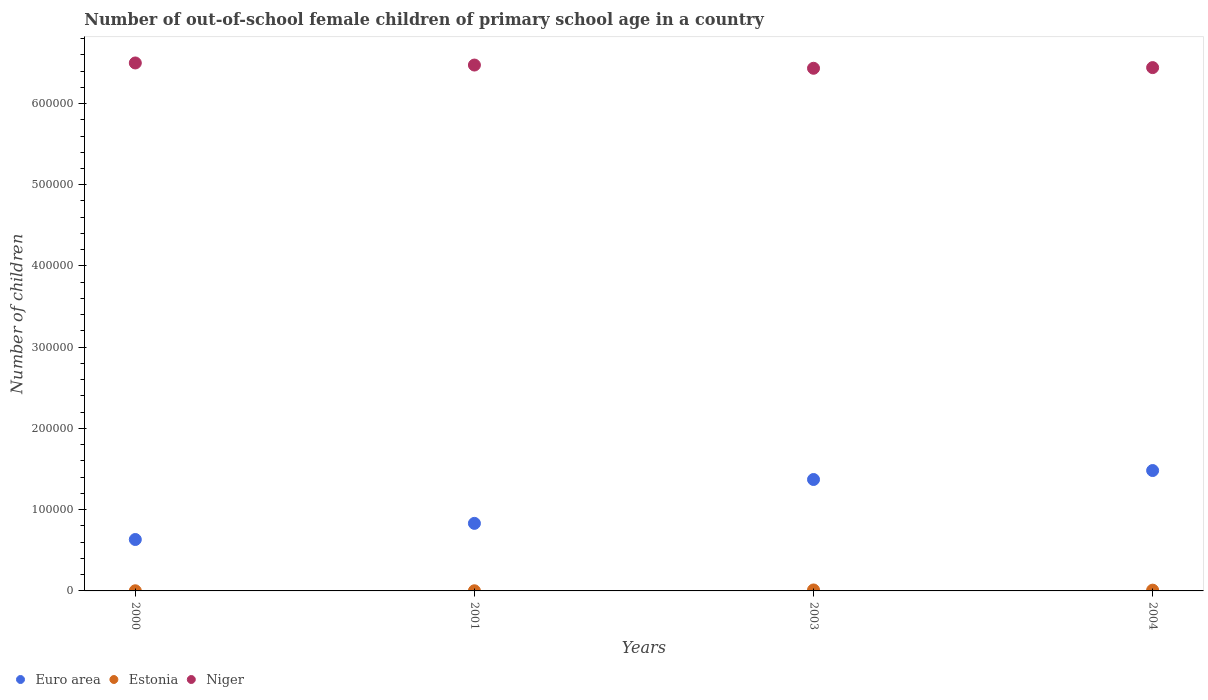What is the number of out-of-school female children in Estonia in 2000?
Ensure brevity in your answer.  177. Across all years, what is the maximum number of out-of-school female children in Euro area?
Give a very brief answer. 1.48e+05. Across all years, what is the minimum number of out-of-school female children in Estonia?
Make the answer very short. 177. What is the total number of out-of-school female children in Euro area in the graph?
Make the answer very short. 4.32e+05. What is the difference between the number of out-of-school female children in Euro area in 2003 and that in 2004?
Your answer should be compact. -1.10e+04. What is the difference between the number of out-of-school female children in Estonia in 2000 and the number of out-of-school female children in Niger in 2001?
Offer a very short reply. -6.47e+05. What is the average number of out-of-school female children in Niger per year?
Your answer should be compact. 6.46e+05. In the year 2004, what is the difference between the number of out-of-school female children in Niger and number of out-of-school female children in Euro area?
Offer a terse response. 4.96e+05. What is the ratio of the number of out-of-school female children in Estonia in 2000 to that in 2003?
Offer a very short reply. 0.15. What is the difference between the highest and the second highest number of out-of-school female children in Niger?
Keep it short and to the point. 2564. What is the difference between the highest and the lowest number of out-of-school female children in Niger?
Give a very brief answer. 6531. In how many years, is the number of out-of-school female children in Niger greater than the average number of out-of-school female children in Niger taken over all years?
Provide a succinct answer. 2. Does the number of out-of-school female children in Estonia monotonically increase over the years?
Make the answer very short. No. Is the number of out-of-school female children in Euro area strictly greater than the number of out-of-school female children in Niger over the years?
Provide a succinct answer. No. How many dotlines are there?
Make the answer very short. 3. Are the values on the major ticks of Y-axis written in scientific E-notation?
Give a very brief answer. No. Does the graph contain grids?
Provide a succinct answer. No. How many legend labels are there?
Provide a short and direct response. 3. How are the legend labels stacked?
Keep it short and to the point. Horizontal. What is the title of the graph?
Provide a short and direct response. Number of out-of-school female children of primary school age in a country. What is the label or title of the X-axis?
Offer a terse response. Years. What is the label or title of the Y-axis?
Keep it short and to the point. Number of children. What is the Number of children of Euro area in 2000?
Provide a short and direct response. 6.33e+04. What is the Number of children of Estonia in 2000?
Give a very brief answer. 177. What is the Number of children of Niger in 2000?
Provide a succinct answer. 6.50e+05. What is the Number of children of Euro area in 2001?
Provide a short and direct response. 8.32e+04. What is the Number of children of Estonia in 2001?
Your answer should be compact. 183. What is the Number of children in Niger in 2001?
Your answer should be compact. 6.47e+05. What is the Number of children of Euro area in 2003?
Keep it short and to the point. 1.37e+05. What is the Number of children of Estonia in 2003?
Ensure brevity in your answer.  1186. What is the Number of children in Niger in 2003?
Your answer should be compact. 6.43e+05. What is the Number of children of Euro area in 2004?
Make the answer very short. 1.48e+05. What is the Number of children of Estonia in 2004?
Keep it short and to the point. 944. What is the Number of children of Niger in 2004?
Provide a short and direct response. 6.44e+05. Across all years, what is the maximum Number of children in Euro area?
Provide a short and direct response. 1.48e+05. Across all years, what is the maximum Number of children of Estonia?
Keep it short and to the point. 1186. Across all years, what is the maximum Number of children in Niger?
Your response must be concise. 6.50e+05. Across all years, what is the minimum Number of children in Euro area?
Offer a very short reply. 6.33e+04. Across all years, what is the minimum Number of children in Estonia?
Your response must be concise. 177. Across all years, what is the minimum Number of children in Niger?
Ensure brevity in your answer.  6.43e+05. What is the total Number of children of Euro area in the graph?
Give a very brief answer. 4.32e+05. What is the total Number of children of Estonia in the graph?
Ensure brevity in your answer.  2490. What is the total Number of children of Niger in the graph?
Ensure brevity in your answer.  2.58e+06. What is the difference between the Number of children in Euro area in 2000 and that in 2001?
Give a very brief answer. -1.99e+04. What is the difference between the Number of children of Estonia in 2000 and that in 2001?
Offer a very short reply. -6. What is the difference between the Number of children of Niger in 2000 and that in 2001?
Offer a terse response. 2564. What is the difference between the Number of children in Euro area in 2000 and that in 2003?
Keep it short and to the point. -7.39e+04. What is the difference between the Number of children of Estonia in 2000 and that in 2003?
Your answer should be very brief. -1009. What is the difference between the Number of children of Niger in 2000 and that in 2003?
Give a very brief answer. 6531. What is the difference between the Number of children in Euro area in 2000 and that in 2004?
Your response must be concise. -8.49e+04. What is the difference between the Number of children of Estonia in 2000 and that in 2004?
Your answer should be very brief. -767. What is the difference between the Number of children in Niger in 2000 and that in 2004?
Keep it short and to the point. 5714. What is the difference between the Number of children in Euro area in 2001 and that in 2003?
Your response must be concise. -5.40e+04. What is the difference between the Number of children in Estonia in 2001 and that in 2003?
Your response must be concise. -1003. What is the difference between the Number of children of Niger in 2001 and that in 2003?
Your answer should be very brief. 3967. What is the difference between the Number of children in Euro area in 2001 and that in 2004?
Your answer should be very brief. -6.50e+04. What is the difference between the Number of children in Estonia in 2001 and that in 2004?
Your answer should be compact. -761. What is the difference between the Number of children in Niger in 2001 and that in 2004?
Offer a terse response. 3150. What is the difference between the Number of children in Euro area in 2003 and that in 2004?
Ensure brevity in your answer.  -1.10e+04. What is the difference between the Number of children of Estonia in 2003 and that in 2004?
Keep it short and to the point. 242. What is the difference between the Number of children of Niger in 2003 and that in 2004?
Make the answer very short. -817. What is the difference between the Number of children in Euro area in 2000 and the Number of children in Estonia in 2001?
Your response must be concise. 6.31e+04. What is the difference between the Number of children in Euro area in 2000 and the Number of children in Niger in 2001?
Offer a terse response. -5.84e+05. What is the difference between the Number of children of Estonia in 2000 and the Number of children of Niger in 2001?
Provide a succinct answer. -6.47e+05. What is the difference between the Number of children of Euro area in 2000 and the Number of children of Estonia in 2003?
Your answer should be compact. 6.21e+04. What is the difference between the Number of children in Euro area in 2000 and the Number of children in Niger in 2003?
Your answer should be compact. -5.80e+05. What is the difference between the Number of children in Estonia in 2000 and the Number of children in Niger in 2003?
Give a very brief answer. -6.43e+05. What is the difference between the Number of children of Euro area in 2000 and the Number of children of Estonia in 2004?
Offer a very short reply. 6.24e+04. What is the difference between the Number of children of Euro area in 2000 and the Number of children of Niger in 2004?
Keep it short and to the point. -5.81e+05. What is the difference between the Number of children in Estonia in 2000 and the Number of children in Niger in 2004?
Give a very brief answer. -6.44e+05. What is the difference between the Number of children in Euro area in 2001 and the Number of children in Estonia in 2003?
Your answer should be compact. 8.20e+04. What is the difference between the Number of children in Euro area in 2001 and the Number of children in Niger in 2003?
Provide a succinct answer. -5.60e+05. What is the difference between the Number of children in Estonia in 2001 and the Number of children in Niger in 2003?
Your response must be concise. -6.43e+05. What is the difference between the Number of children in Euro area in 2001 and the Number of children in Estonia in 2004?
Provide a succinct answer. 8.22e+04. What is the difference between the Number of children in Euro area in 2001 and the Number of children in Niger in 2004?
Provide a short and direct response. -5.61e+05. What is the difference between the Number of children in Estonia in 2001 and the Number of children in Niger in 2004?
Your response must be concise. -6.44e+05. What is the difference between the Number of children in Euro area in 2003 and the Number of children in Estonia in 2004?
Your answer should be compact. 1.36e+05. What is the difference between the Number of children of Euro area in 2003 and the Number of children of Niger in 2004?
Offer a very short reply. -5.07e+05. What is the difference between the Number of children of Estonia in 2003 and the Number of children of Niger in 2004?
Offer a terse response. -6.43e+05. What is the average Number of children in Euro area per year?
Provide a succinct answer. 1.08e+05. What is the average Number of children of Estonia per year?
Give a very brief answer. 622.5. What is the average Number of children in Niger per year?
Offer a very short reply. 6.46e+05. In the year 2000, what is the difference between the Number of children of Euro area and Number of children of Estonia?
Your response must be concise. 6.31e+04. In the year 2000, what is the difference between the Number of children in Euro area and Number of children in Niger?
Your answer should be compact. -5.87e+05. In the year 2000, what is the difference between the Number of children of Estonia and Number of children of Niger?
Your answer should be very brief. -6.50e+05. In the year 2001, what is the difference between the Number of children in Euro area and Number of children in Estonia?
Your response must be concise. 8.30e+04. In the year 2001, what is the difference between the Number of children of Euro area and Number of children of Niger?
Offer a terse response. -5.64e+05. In the year 2001, what is the difference between the Number of children in Estonia and Number of children in Niger?
Your answer should be compact. -6.47e+05. In the year 2003, what is the difference between the Number of children of Euro area and Number of children of Estonia?
Offer a terse response. 1.36e+05. In the year 2003, what is the difference between the Number of children in Euro area and Number of children in Niger?
Your answer should be compact. -5.06e+05. In the year 2003, what is the difference between the Number of children of Estonia and Number of children of Niger?
Your answer should be compact. -6.42e+05. In the year 2004, what is the difference between the Number of children in Euro area and Number of children in Estonia?
Your answer should be very brief. 1.47e+05. In the year 2004, what is the difference between the Number of children in Euro area and Number of children in Niger?
Make the answer very short. -4.96e+05. In the year 2004, what is the difference between the Number of children in Estonia and Number of children in Niger?
Offer a very short reply. -6.43e+05. What is the ratio of the Number of children of Euro area in 2000 to that in 2001?
Your response must be concise. 0.76. What is the ratio of the Number of children of Estonia in 2000 to that in 2001?
Give a very brief answer. 0.97. What is the ratio of the Number of children in Euro area in 2000 to that in 2003?
Make the answer very short. 0.46. What is the ratio of the Number of children of Estonia in 2000 to that in 2003?
Make the answer very short. 0.15. What is the ratio of the Number of children of Niger in 2000 to that in 2003?
Provide a short and direct response. 1.01. What is the ratio of the Number of children of Euro area in 2000 to that in 2004?
Offer a terse response. 0.43. What is the ratio of the Number of children of Estonia in 2000 to that in 2004?
Your response must be concise. 0.19. What is the ratio of the Number of children of Niger in 2000 to that in 2004?
Offer a very short reply. 1.01. What is the ratio of the Number of children in Euro area in 2001 to that in 2003?
Make the answer very short. 0.61. What is the ratio of the Number of children of Estonia in 2001 to that in 2003?
Your answer should be compact. 0.15. What is the ratio of the Number of children of Euro area in 2001 to that in 2004?
Ensure brevity in your answer.  0.56. What is the ratio of the Number of children in Estonia in 2001 to that in 2004?
Offer a terse response. 0.19. What is the ratio of the Number of children of Niger in 2001 to that in 2004?
Offer a very short reply. 1. What is the ratio of the Number of children in Euro area in 2003 to that in 2004?
Offer a very short reply. 0.93. What is the ratio of the Number of children in Estonia in 2003 to that in 2004?
Offer a terse response. 1.26. What is the ratio of the Number of children of Niger in 2003 to that in 2004?
Offer a terse response. 1. What is the difference between the highest and the second highest Number of children of Euro area?
Give a very brief answer. 1.10e+04. What is the difference between the highest and the second highest Number of children in Estonia?
Keep it short and to the point. 242. What is the difference between the highest and the second highest Number of children of Niger?
Keep it short and to the point. 2564. What is the difference between the highest and the lowest Number of children in Euro area?
Ensure brevity in your answer.  8.49e+04. What is the difference between the highest and the lowest Number of children of Estonia?
Keep it short and to the point. 1009. What is the difference between the highest and the lowest Number of children in Niger?
Give a very brief answer. 6531. 